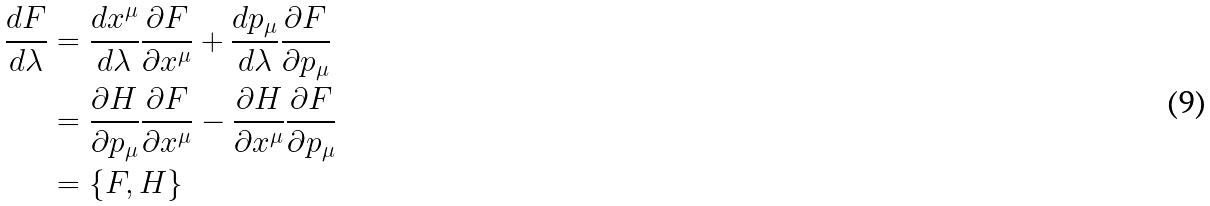<formula> <loc_0><loc_0><loc_500><loc_500>\frac { d F } { d \lambda } & = \frac { d x ^ { \mu } } { d \lambda } \frac { \partial F } { \partial x ^ { \mu } } + \frac { d p _ { \mu } } { d \lambda } \frac { \partial F } { \partial p _ { \mu } } \\ & = \frac { \partial H } { \partial p _ { \mu } } \frac { \partial F } { \partial x ^ { \mu } } - \frac { \partial H } { \partial x ^ { \mu } } \frac { \partial F } { \partial p _ { \mu } } \\ & = \{ F , H \}</formula> 